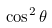Convert formula to latex. <formula><loc_0><loc_0><loc_500><loc_500>\cos ^ { 2 } \theta</formula> 